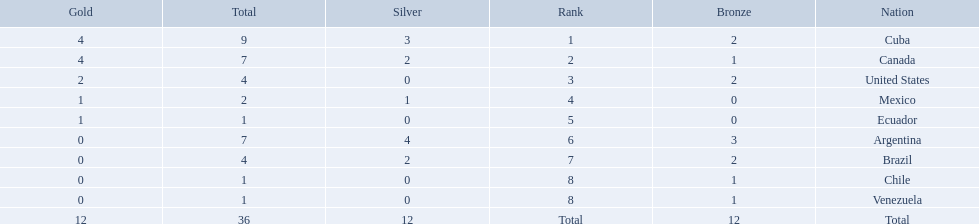What were the amounts of bronze medals won by the countries? 2, 1, 2, 0, 0, 3, 2, 1, 1. Which is the highest? 3. Which nation had this amount? Argentina. 